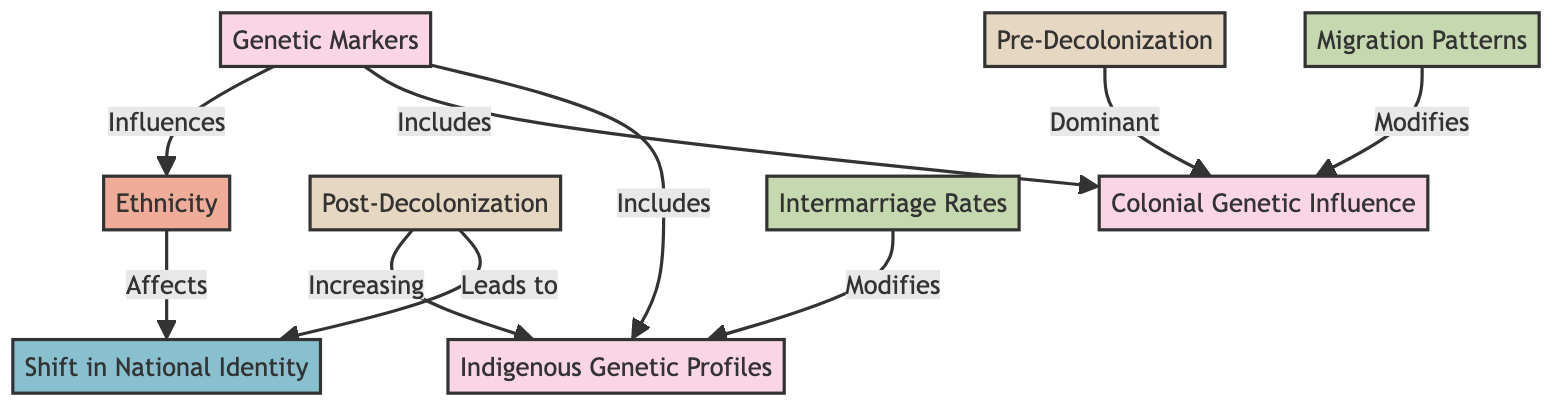What are the two main periods indicated in the diagram? The diagram specifies two periods, labeled as "Pre-Decolonization" and "Post-Decolonization." These are clearly indicated as major categories in the flowchart.
Answer: Pre-Decolonization, Post-Decolonization Which node indicates the dominant influence during the Pre-Decolonization period? The flowchart shows that the node "Colonial Genetic Influence" is associated with the Pre-Decolonization period, indicating it was the dominant influence on genetic markers at that time.
Answer: Colonial Genetic Influence What does the Post-Decolonization period lead to? According to the relationships depicted in the diagram, the Post-Decolonization period leads directly to a "Shift in National Identity." This shows the impact of post-colonial changes on how national identity evolves.
Answer: Shift in National Identity How do migration patterns affect genetic markers? The diagram illustrates that "Migration Patterns" modify the "Colonial Genetic Influence." This suggests that movements of people alter the genetic landscape influenced by colonial history.
Answer: Modifies How many influences are shown affecting the indigenous genetic profiles? The diagram presents two influences affecting "Indigenous Genetic Profiles": "Migration Patterns" and "Intermarriage Rates." This indicates that both factors contribute to changes in indigenous genetic markers.
Answer: 2 What is the relationship between ethnicity and national identity? In the diagram, it is indicated that "Ethnicity" affects the "Shift in National Identity," suggesting that the ethnic composition of a nation plays a role in shaping its national identity.
Answer: Affects What are the two genetic markers included in the diagram? The genetic markers highlighted in the diagram are "Colonial Genetic Influence" and "Indigenous Genetic Profiles." These two are the primary components representing genetic diversity in the context of ethnicity.
Answer: Colonial Genetic Influence, Indigenous Genetic Profiles How do intermarriage rates impact indigenous genetic profiles? The diagram indicates that "Intermarriage Rates" modify the "Indigenous Genetic Profiles." This means that as intermarriage increases, it influences the genetic characteristics of indigenous populations.
Answer: Modifies 